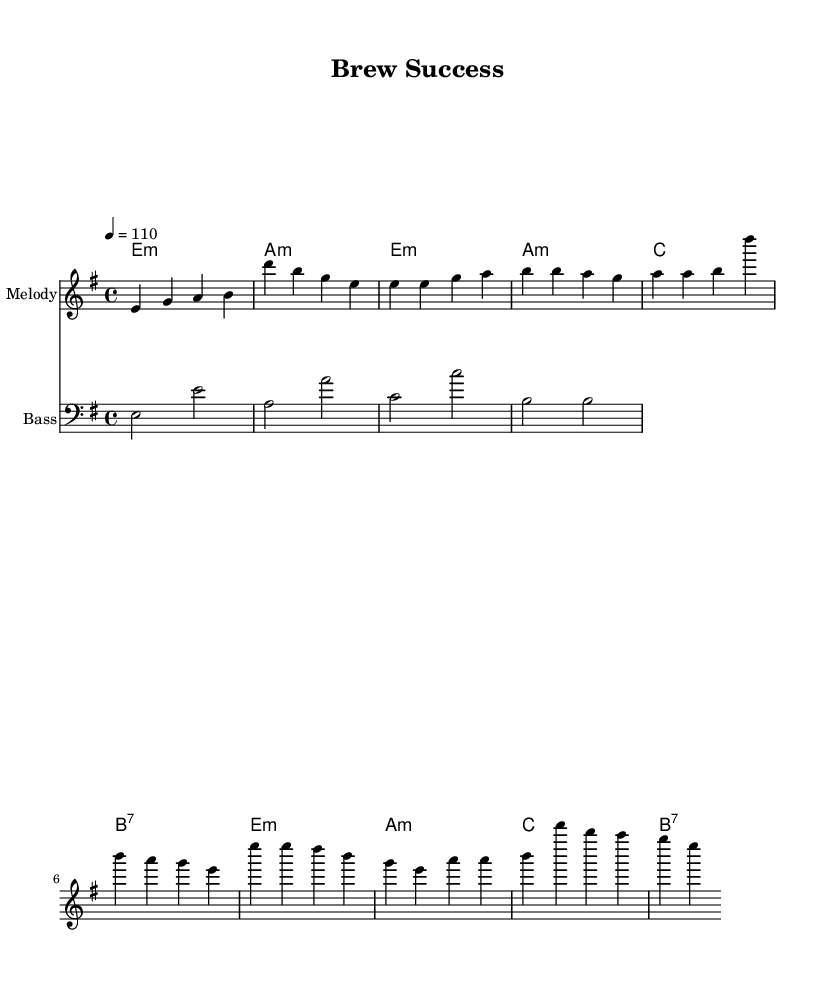What is the key signature of this music? The key signature is E minor, which has one sharp (F#).
Answer: E minor What is the time signature of this music? The time signature is 4/4, indicating four beats per measure.
Answer: 4/4 What is the tempo marking for this music? The tempo marking is quarter note = 110, meaning it should be played at 110 beats per minute.
Answer: 110 How many measures are in the verse section? The verse section consists of four measures based on the melody indicated.
Answer: 4 What is the corresponding chord for the first measure of the chorus? The first measure of the chorus lists the chord E minor, indicated in the harmonies section.
Answer: E minor How do the bass line notes relate to the melody during the chorus? The bass line notes match the root notes of the chords played in the chorus, providing harmonic support to the melody.
Answer: Root notes What genre does this piece represent? The piece is characterized by syncopated rhythms and strong beats typical of funk music, aligning with its designation as a funky anthem.
Answer: Funk 